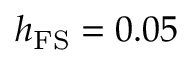Convert formula to latex. <formula><loc_0><loc_0><loc_500><loc_500>h _ { F S } = 0 . 0 5</formula> 